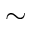<formula> <loc_0><loc_0><loc_500><loc_500>\sim</formula> 